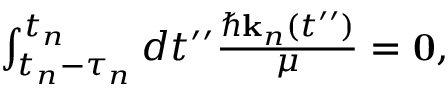Convert formula to latex. <formula><loc_0><loc_0><loc_500><loc_500>\begin{array} { r } { \int _ { t _ { n } - \tau _ { n } } ^ { t _ { n } } d t ^ { \prime \prime } \frac { \hbar { k } _ { n } ( t ^ { \prime \prime } ) } { \mu } = { 0 } , } \end{array}</formula> 